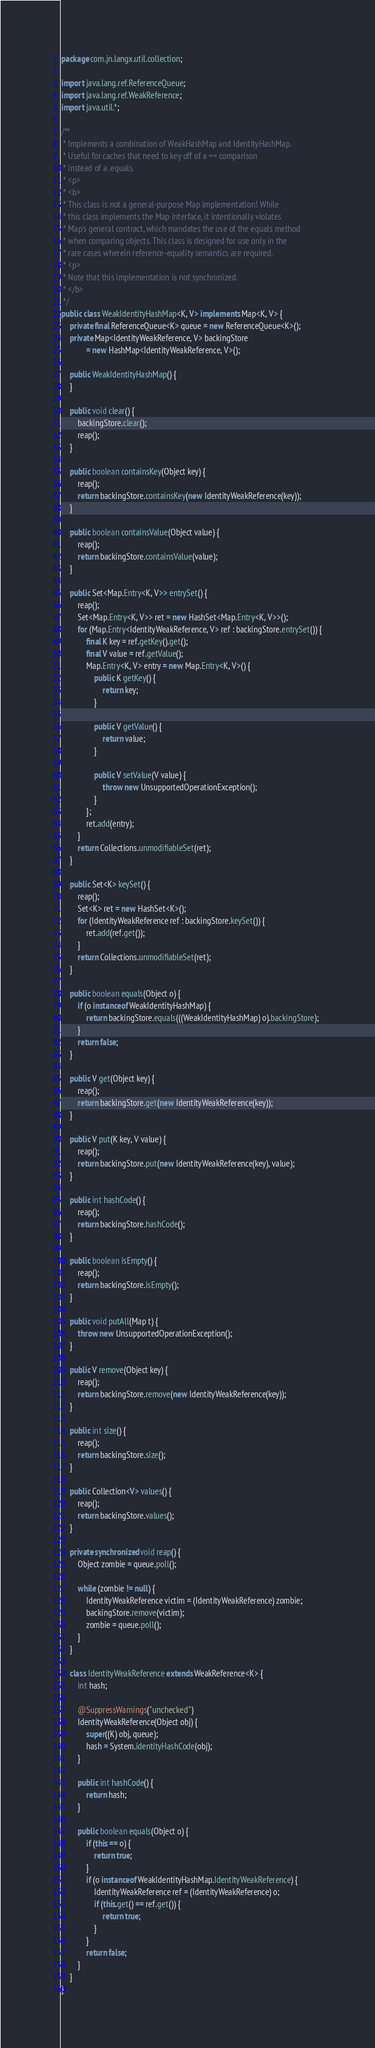Convert code to text. <code><loc_0><loc_0><loc_500><loc_500><_Java_>package com.jn.langx.util.collection;

import java.lang.ref.ReferenceQueue;
import java.lang.ref.WeakReference;
import java.util.*;

/**
 * Implements a combination of WeakHashMap and IdentityHashMap.
 * Useful for caches that need to key off of a == comparison
 * instead of a .equals.
 * <p>
 * <b>
 * This class is not a general-purpose Map implementation! While
 * this class implements the Map interface, it intentionally violates
 * Map's general contract, which mandates the use of the equals method
 * when comparing objects. This class is designed for use only in the
 * rare cases wherein reference-equality semantics are required.
 * <p>
 * Note that this implementation is not synchronized.
 * </b>
 */
public class WeakIdentityHashMap<K, V> implements Map<K, V> {
    private final ReferenceQueue<K> queue = new ReferenceQueue<K>();
    private Map<IdentityWeakReference, V> backingStore
            = new HashMap<IdentityWeakReference, V>();

    public WeakIdentityHashMap() {
    }

    public void clear() {
        backingStore.clear();
        reap();
    }

    public boolean containsKey(Object key) {
        reap();
        return backingStore.containsKey(new IdentityWeakReference(key));
    }

    public boolean containsValue(Object value) {
        reap();
        return backingStore.containsValue(value);
    }

    public Set<Map.Entry<K, V>> entrySet() {
        reap();
        Set<Map.Entry<K, V>> ret = new HashSet<Map.Entry<K, V>>();
        for (Map.Entry<IdentityWeakReference, V> ref : backingStore.entrySet()) {
            final K key = ref.getKey().get();
            final V value = ref.getValue();
            Map.Entry<K, V> entry = new Map.Entry<K, V>() {
                public K getKey() {
                    return key;
                }

                public V getValue() {
                    return value;
                }

                public V setValue(V value) {
                    throw new UnsupportedOperationException();
                }
            };
            ret.add(entry);
        }
        return Collections.unmodifiableSet(ret);
    }

    public Set<K> keySet() {
        reap();
        Set<K> ret = new HashSet<K>();
        for (IdentityWeakReference ref : backingStore.keySet()) {
            ret.add(ref.get());
        }
        return Collections.unmodifiableSet(ret);
    }

    public boolean equals(Object o) {
        if (o instanceof WeakIdentityHashMap) {
            return backingStore.equals(((WeakIdentityHashMap) o).backingStore);
        }
        return false;
    }

    public V get(Object key) {
        reap();
        return backingStore.get(new IdentityWeakReference(key));
    }

    public V put(K key, V value) {
        reap();
        return backingStore.put(new IdentityWeakReference(key), value);
    }

    public int hashCode() {
        reap();
        return backingStore.hashCode();
    }

    public boolean isEmpty() {
        reap();
        return backingStore.isEmpty();
    }

    public void putAll(Map t) {
        throw new UnsupportedOperationException();
    }

    public V remove(Object key) {
        reap();
        return backingStore.remove(new IdentityWeakReference(key));
    }

    public int size() {
        reap();
        return backingStore.size();
    }

    public Collection<V> values() {
        reap();
        return backingStore.values();
    }

    private synchronized void reap() {
        Object zombie = queue.poll();

        while (zombie != null) {
            IdentityWeakReference victim = (IdentityWeakReference) zombie;
            backingStore.remove(victim);
            zombie = queue.poll();
        }
    }

    class IdentityWeakReference extends WeakReference<K> {
        int hash;

        @SuppressWarnings("unchecked")
        IdentityWeakReference(Object obj) {
            super((K) obj, queue);
            hash = System.identityHashCode(obj);
        }

        public int hashCode() {
            return hash;
        }

        public boolean equals(Object o) {
            if (this == o) {
                return true;
            }
            if (o instanceof WeakIdentityHashMap.IdentityWeakReference) {
                IdentityWeakReference ref = (IdentityWeakReference) o;
                if (this.get() == ref.get()) {
                    return true;
                }
            }
            return false;
        }
    }
}
</code> 